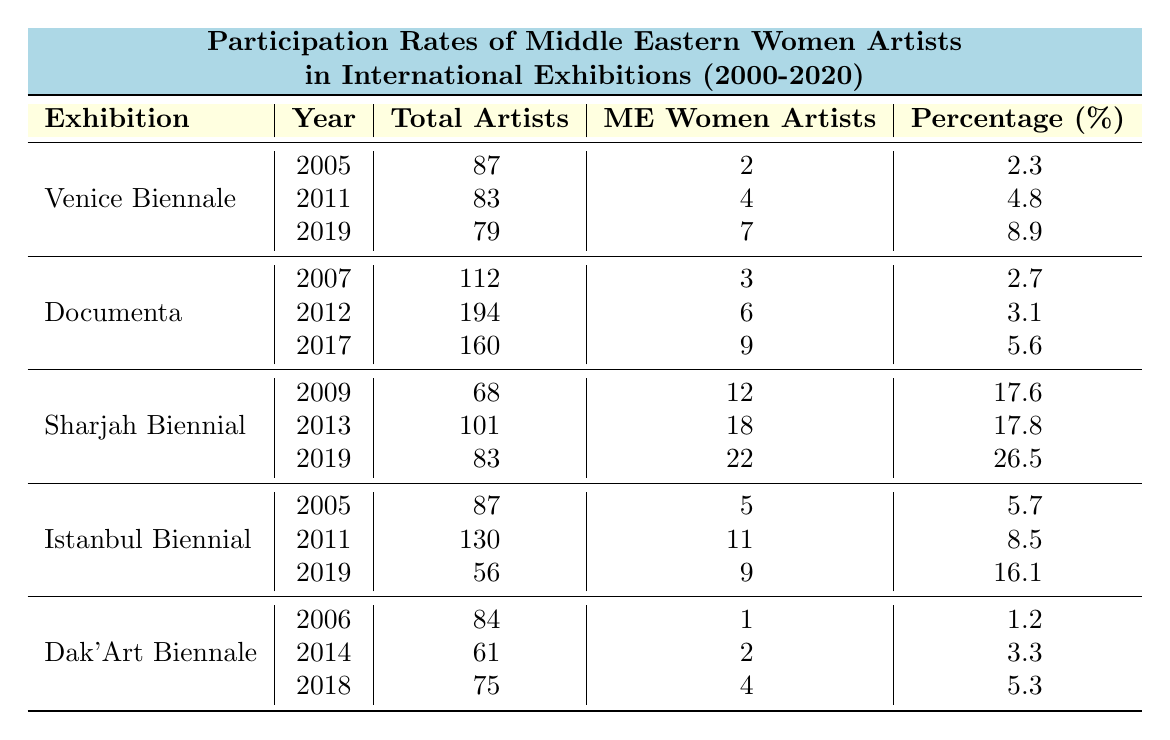What was the highest percentage of Middle Eastern women artists in the Sharjah Biennial? From the table, the highest percentage for Sharjah Biennial is in 2019, where 26.5% of artists were Middle Eastern women.
Answer: 26.5% How many Middle Eastern women artists participated in the Venice Biennale in 2005? Looking at the 2005 row for the Venice Biennale, it shows that 2 Middle Eastern women artists participated.
Answer: 2 What is the total number of Middle Eastern women artists from the Istanbul Biennial across all years? The values for Middle Eastern women artists from the Istanbul Biennial in 2005, 2011, and 2019 are 5, 11, and 9 respectively. Adding them gives 5 + 11 + 9 = 25.
Answer: 25 Did the percentage of Middle Eastern women artists increase in the Documenta from 2007 to 2017? In Documenta, the percentages were 2.7% in 2007 and increased to 5.6% in 2017. Therefore, yes, it increased.
Answer: Yes What was the overall trend in participation rates of Middle Eastern women artists in the Sharjah Biennial from 2009 to 2019? In the Sharjah Biennial, participation rates were 17.6% in 2009, 17.8% in 2013, and then rose significantly to 26.5% in 2019. This indicates an overall increasing trend.
Answer: Increasing How many more Middle Eastern women artists were in the Sharjah Biennial in 2019 compared to the Documenta in 2017? In the Sharjah Biennial in 2019, there were 22 Middle Eastern women artists, while in Documenta in 2017, there were 9. The difference is 22 - 9 = 13.
Answer: 13 Is there a year when no Middle Eastern women artists participated in Dak'Art Biennale? No, the data shows that there was at least 1 participant from Middle Eastern women artists in all the years listed for Dak'Art Biennale.
Answer: No What was the average percentage of Middle Eastern women artists across all years in the Venice Biennale? The percentages for the Venice Biennale are 2.3%, 4.8%, and 8.9%. The average is (2.3 + 4.8 + 8.9) / 3 = 5.33%.
Answer: 5.33% In which exhibition did Middle Eastern women artists have the highest participation in 2019? In 2019, the Sharjah Biennial had the highest participation of Middle Eastern women artists with 22 participants.
Answer: Sharjah Biennial What is the total number of artists in the Dak'Art Biennale from 2006 to 2018? The total for Dak'Art Biennale across the years is 84 (2006) + 61 (2014) + 75 (2018) = 220 artists.
Answer: 220 What percentage of total artists in Istanbul Biennial in 2019 were Middle Eastern women? In 2019, the total for Istanbul Biennial was 56, with 9 being Middle Eastern women artists. The percentage is (9 / 56) * 100 = 16.1%.
Answer: 16.1% 